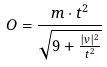Convert formula to latex. <formula><loc_0><loc_0><loc_500><loc_500>O = \frac { m \cdot t ^ { 2 } } { \sqrt { 9 + \frac { | v | ^ { 2 } } { t ^ { 2 } } } }</formula> 